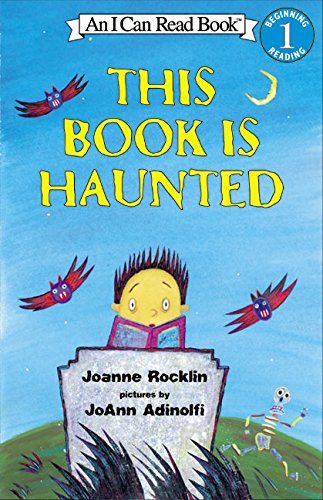What is the title of this book? The title of the book is 'This Book Is Haunted', which is part of the 'I Can Read' series specifically designed to support young readers. 